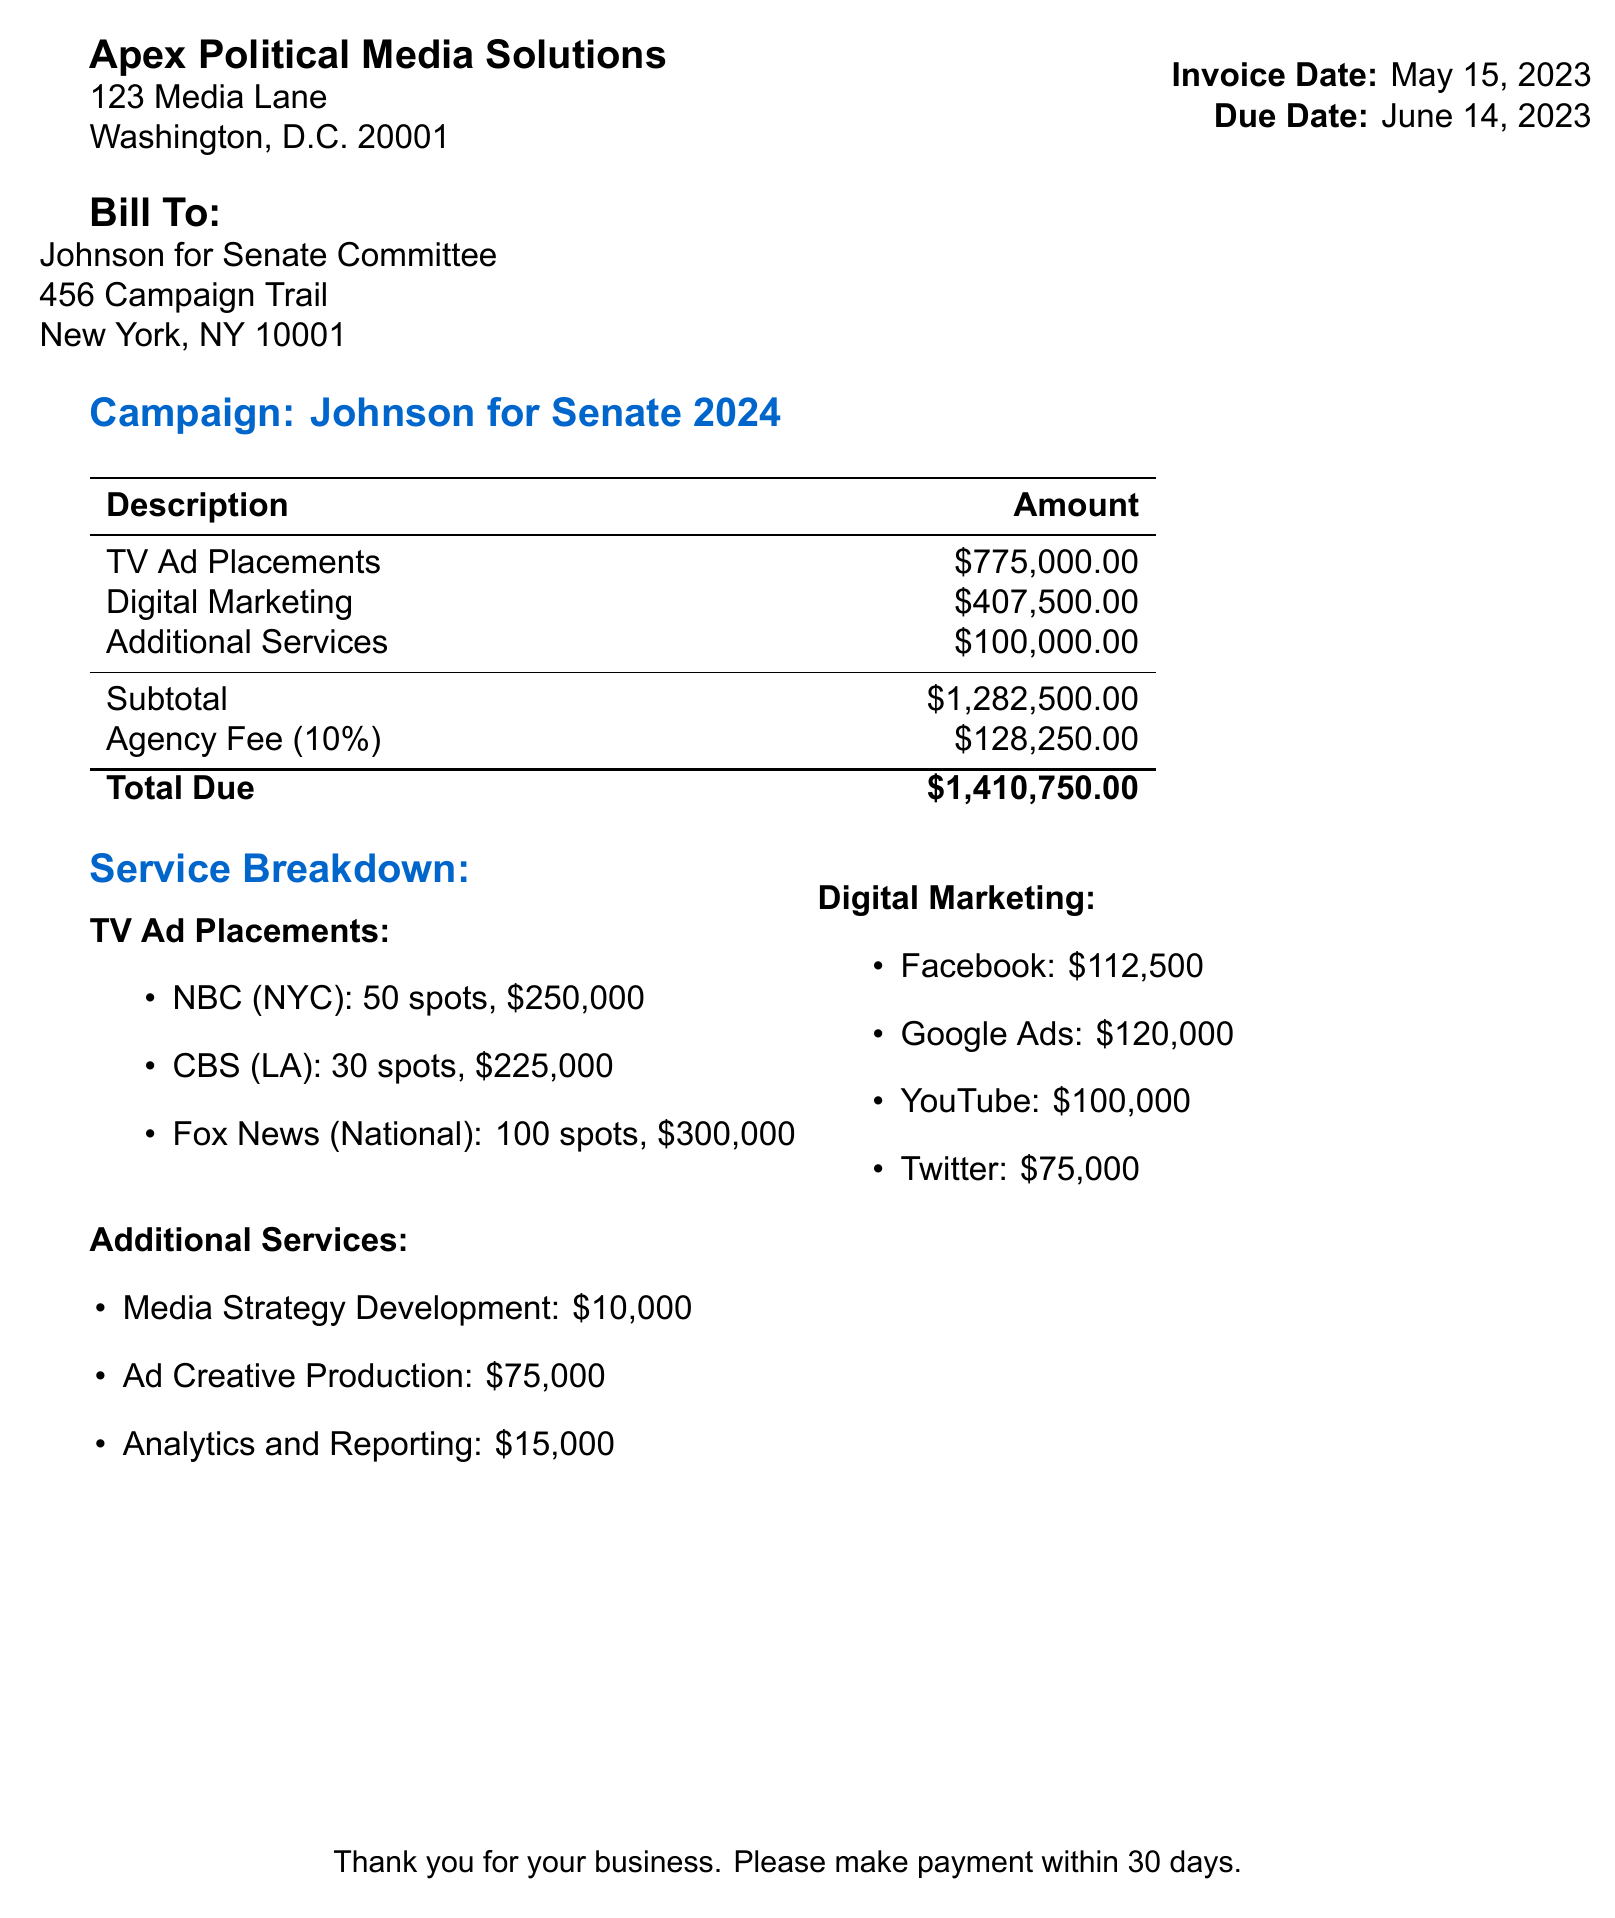What is the invoice number? The invoice number is specified at the top of the document.
Answer: INV-2023-0542 What is the total cost for digital marketing? The total cost for digital marketing is summed from the individual costs listed under digital marketing services.
Answer: $407,500 How many spots were purchased on CBS? The number of spots for CBS is explicitly stated in the ad placements section.
Answer: 30 What is the total due for this invoice? The total due is found in the summary section at the end of the document.
Answer: $1,410,750 What is the service fee for media strategy development? The service fee is listed in the additional services section.
Answer: $10,000 How many prime time spots were purchased on Fox News? The number of prime time spots is provided in the details for Fox News in the TV ad placements section.
Answer: 40 What type of ads were used on Facebook? The type of ads is mentioned in the digital marketing costs section.
Answer: Carousel Ads What is the agency fee percentage? The agency fee percentage is noted in the summary section of the document.
Answer: 10% What is the duration of TV spots on NBC? The duration of TV spots on NBC is detailed in the TV ad placements section.
Answer: 30 seconds 